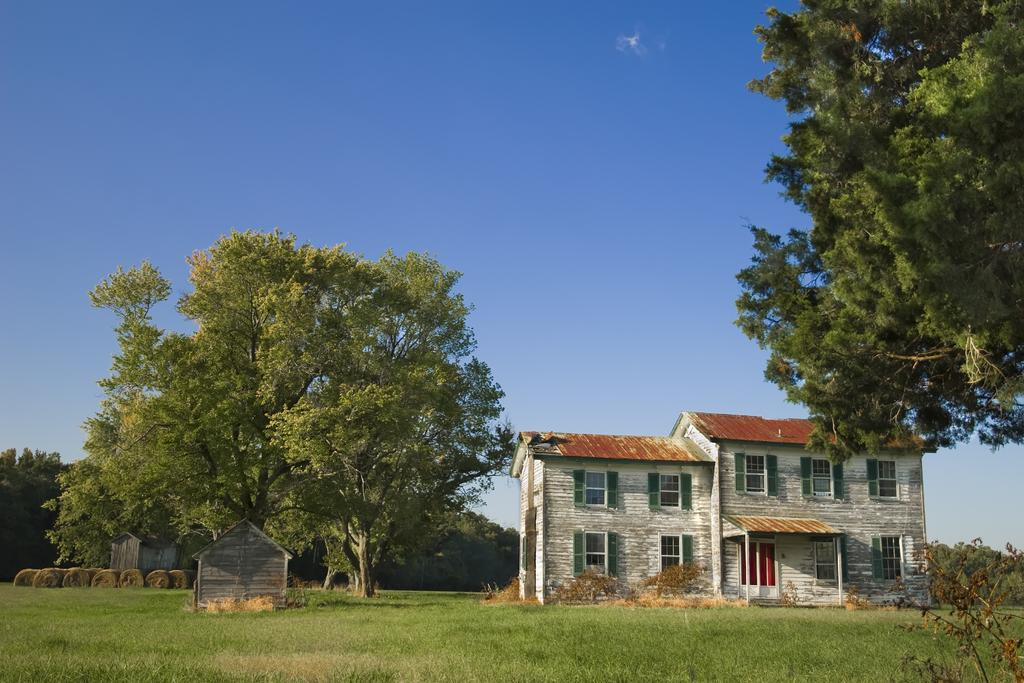What type of structure is present in the image? There is a building in the image. What feature can be seen on the building? The building has windows. What type of vegetation is visible in the image? There is grass visible in the image. What type of plant is present in the image? There is a tree in the image. What is visible in the background of the image? The sky is visible in the image. Can you tell me how many gallons of oil are stored in the building in the image? There is no information about oil storage in the building in the image, so it cannot be determined. 